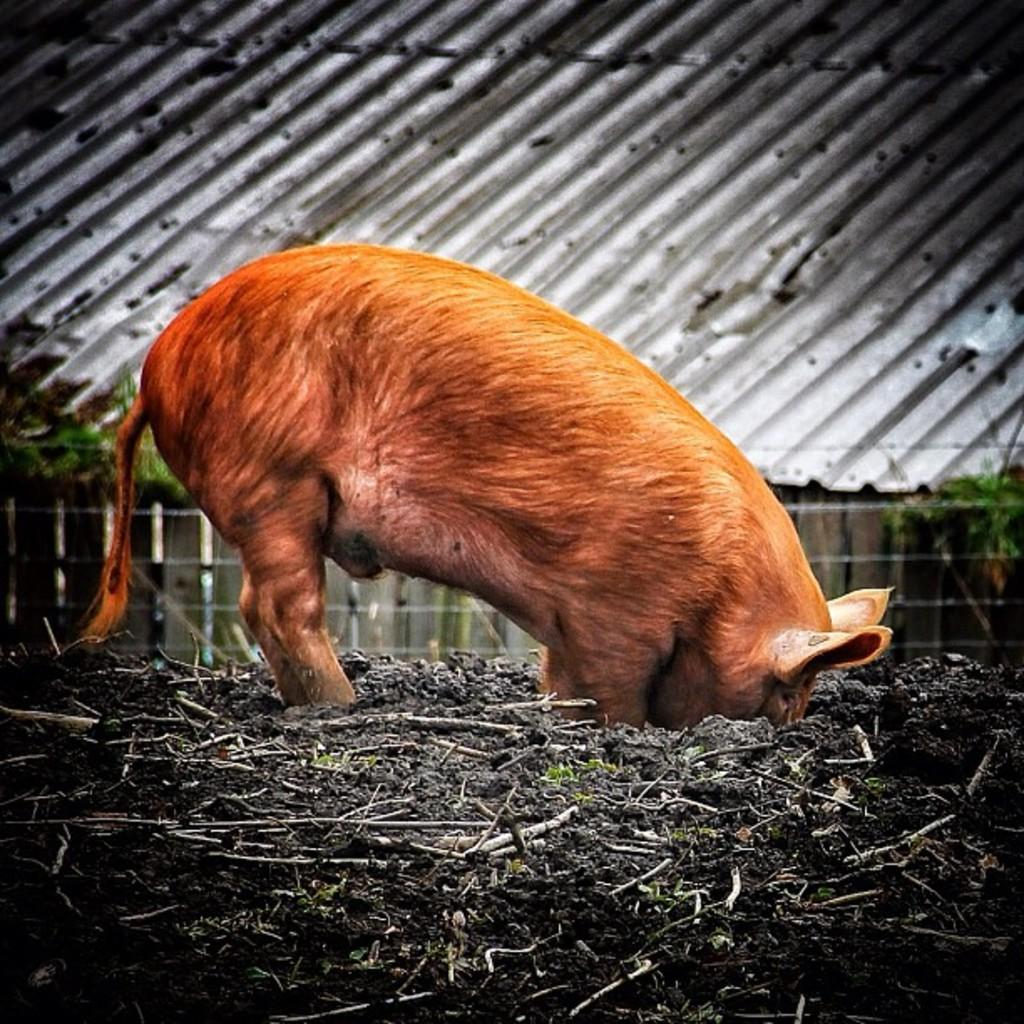What type of animal can be seen on the ground in the image? The image contains an animal on the ground, but the specific type of animal is not mentioned in the facts provided. What can be seen in the background of the image? In the background of the image, there is a grille and roof sheets. Can you describe the setting of the image? The image shows an animal on the ground, with a grille and roof sheets in the background, suggesting an outdoor or semi-enclosed area. What hobbies does the animal on the ground in the image enjoy? There is no information provided about the animal's hobbies in the image. 